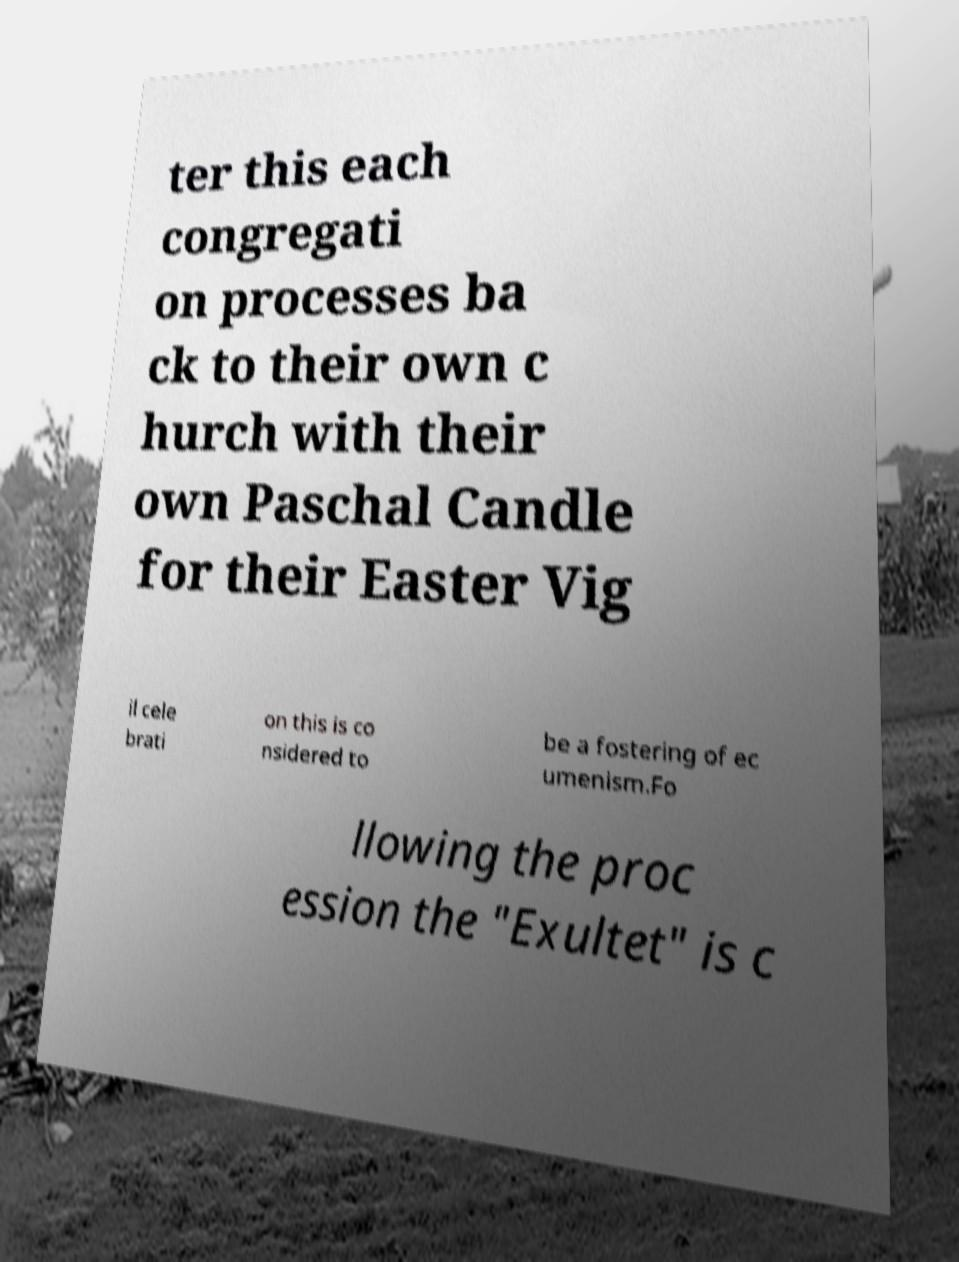Can you read and provide the text displayed in the image?This photo seems to have some interesting text. Can you extract and type it out for me? ter this each congregati on processes ba ck to their own c hurch with their own Paschal Candle for their Easter Vig il cele brati on this is co nsidered to be a fostering of ec umenism.Fo llowing the proc ession the "Exultet" is c 